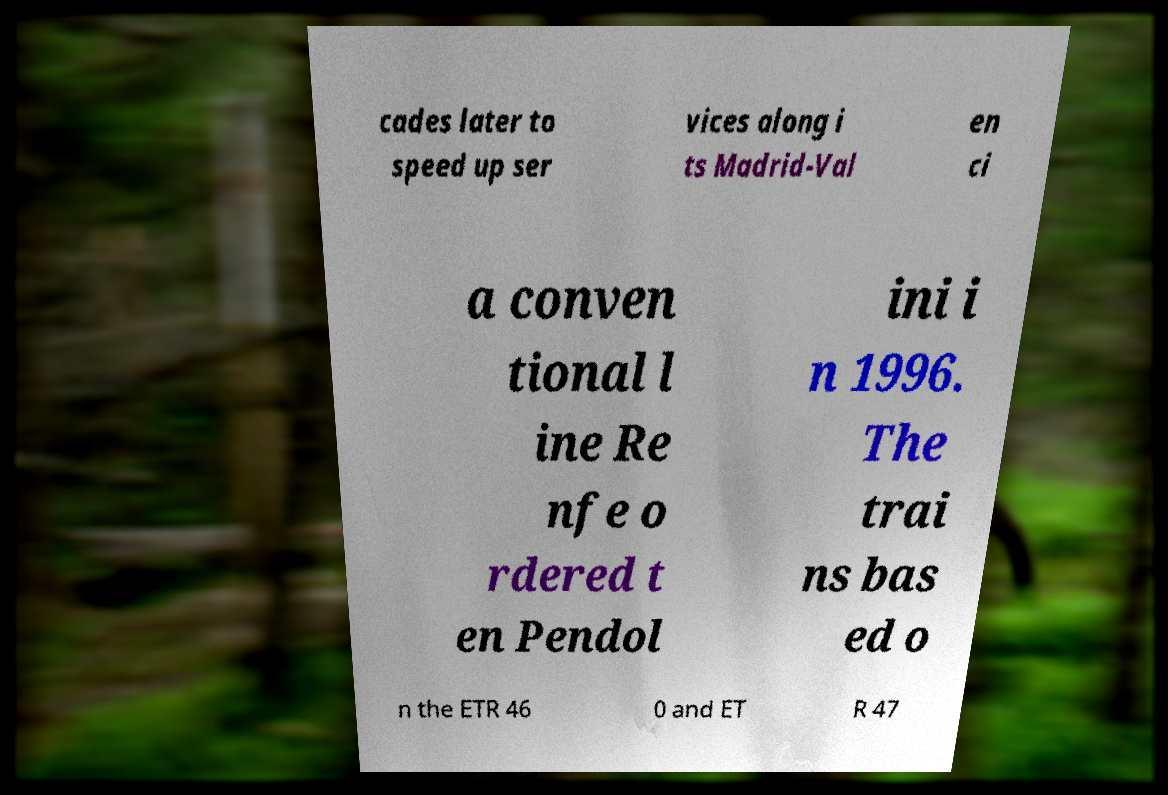Please identify and transcribe the text found in this image. cades later to speed up ser vices along i ts Madrid-Val en ci a conven tional l ine Re nfe o rdered t en Pendol ini i n 1996. The trai ns bas ed o n the ETR 46 0 and ET R 47 